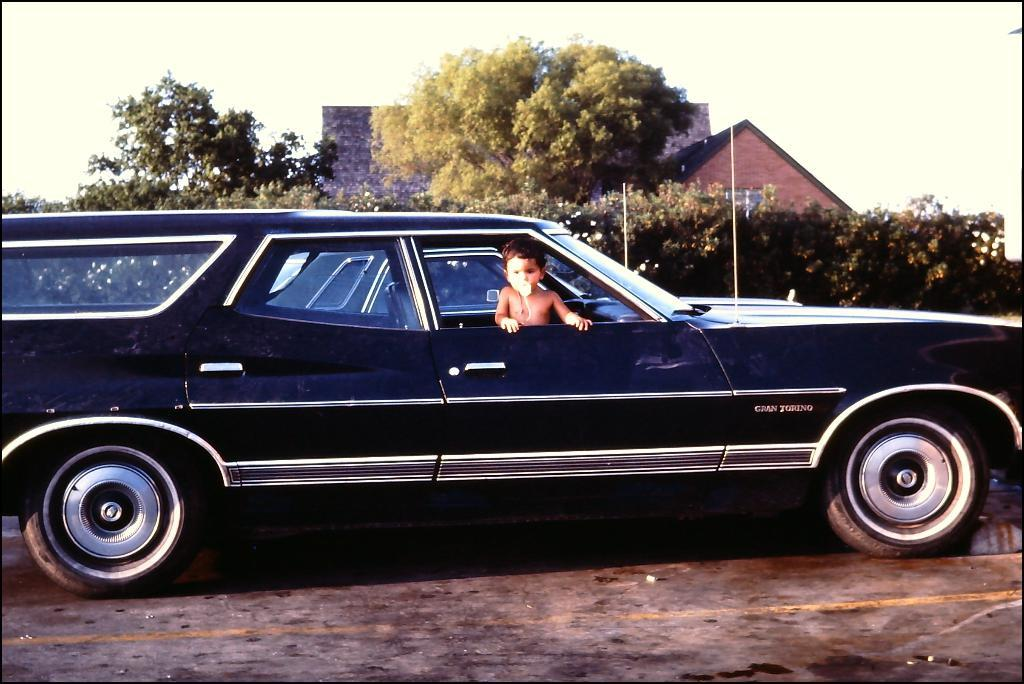What color is the car in the image? The car in the image is black. Where is the car located in the image? The car is on the road. Who is inside the car? There is a kid sitting in the car. What can be seen in the background of the image? There are trees, houses, and a clear sky in the background of the image. What type of wind can be seen blowing through the car in the image? There is no wind visible in the image, and the car is not affected by any wind. 